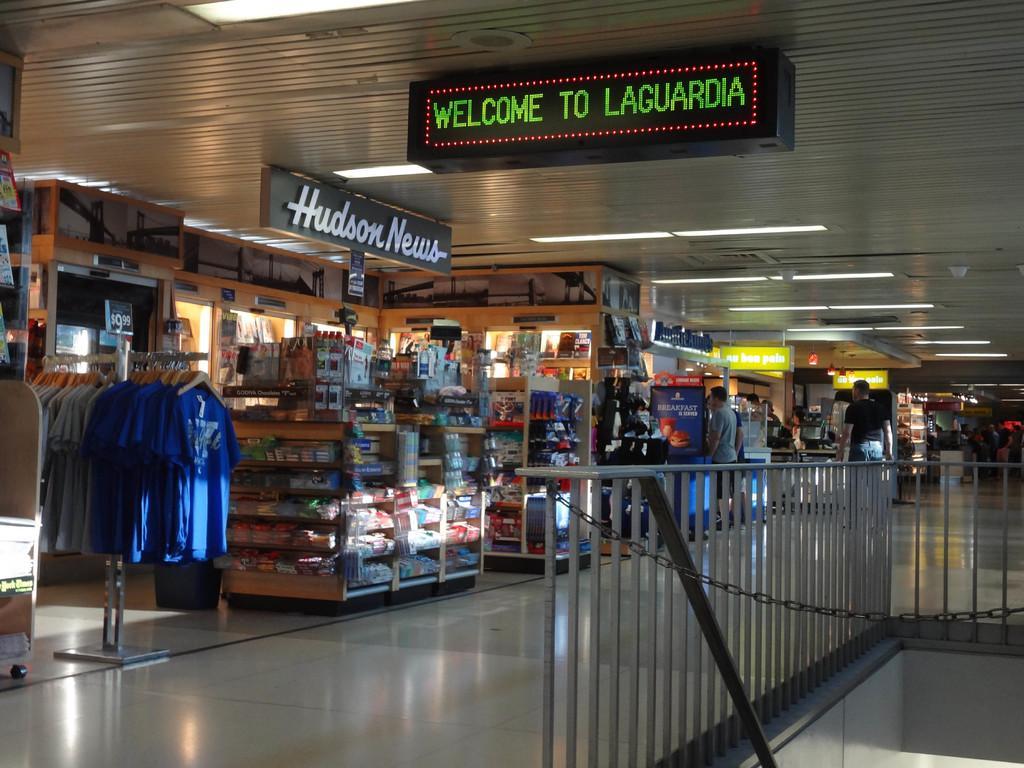Describe this image in one or two sentences. In this image there are few shops in the mall, there is a chain, fence, few object arranged in the racks, some clothes to the hangers and a board attached to the roof and some name board to the shops. 